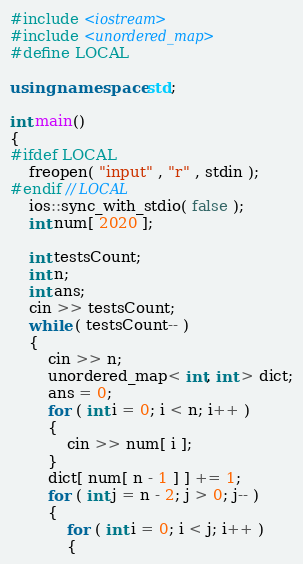Convert code to text. <code><loc_0><loc_0><loc_500><loc_500><_C++_>#include <iostream>
#include <unordered_map>
#define LOCAL

using namespace std;

int main()
{
#ifdef LOCAL
    freopen( "input" , "r" , stdin );
#endif // LOCAL
    ios::sync_with_stdio( false );
    int num[ 2020 ];
    
    int testsCount;
    int n;
    int ans;
    cin >> testsCount;
    while ( testsCount-- )
    {
        cin >> n;
        unordered_map< int, int > dict;
        ans = 0;
        for ( int i = 0; i < n; i++ )
        {
            cin >> num[ i ];
        }
        dict[ num[ n - 1 ] ] += 1;
        for ( int j = n - 2; j > 0; j-- )
        {
            for ( int i = 0; i < j; i++ )
            {</code> 